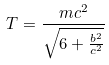Convert formula to latex. <formula><loc_0><loc_0><loc_500><loc_500>T = \frac { m c ^ { 2 } } { \sqrt { 6 + \frac { b ^ { 2 } } { c ^ { 2 } } } }</formula> 